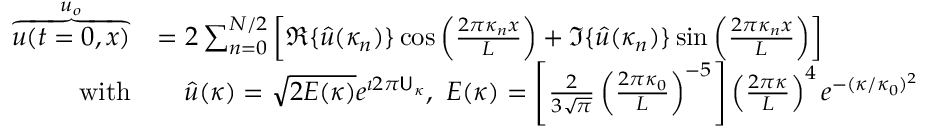<formula> <loc_0><loc_0><loc_500><loc_500>\begin{array} { r l } { \overbrace { u ( t = 0 , x ) } ^ { u _ { o } } } & { = 2 \sum _ { n = 0 } ^ { N / 2 } \left [ \Re \{ \hat { u } ( \kappa _ { n } ) \} \cos \left ( \frac { 2 \pi \kappa _ { n } x } { L } \right ) + \Im \{ \hat { u } ( \kappa _ { n } ) \} \sin \left ( \frac { 2 \pi \kappa _ { n } x } { L } \right ) \right ] } \\ { w i t h } & { \quad \hat { u } ( \kappa ) = \sqrt { 2 E ( \kappa ) } e ^ { \imath 2 \pi U _ { \kappa } } , \ E ( \kappa ) = \left [ \frac { 2 } { 3 \sqrt { \pi } } \left ( \frac { 2 \pi \kappa _ { 0 } } { L } \right ) ^ { - 5 } \right ] \left ( \frac { 2 \pi \kappa } { L } \right ) ^ { 4 } e ^ { - ( \kappa / \kappa _ { 0 } ) ^ { 2 } } } \end{array}</formula> 